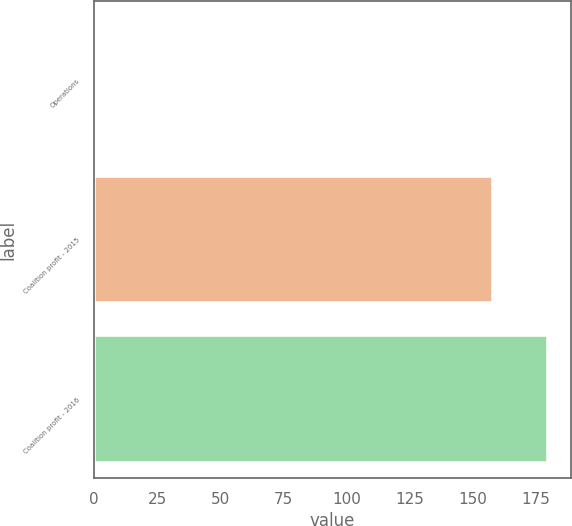Convert chart. <chart><loc_0><loc_0><loc_500><loc_500><bar_chart><fcel>Operations<fcel>Coalition profit - 2015<fcel>Coalition profit - 2016<nl><fcel>0.6<fcel>158<fcel>179.8<nl></chart> 